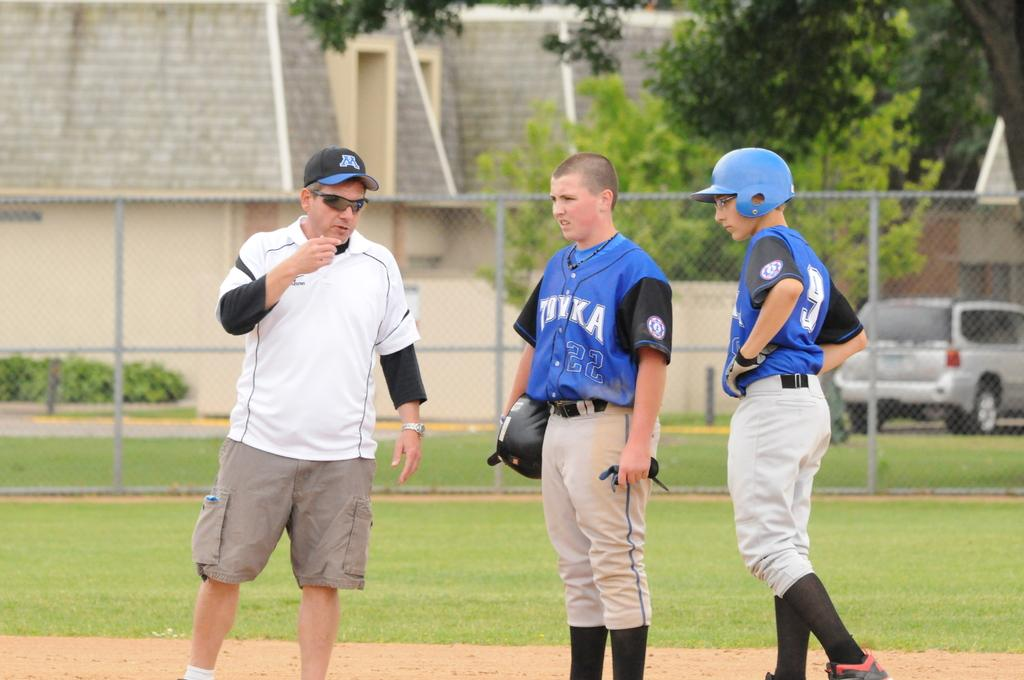<image>
Present a compact description of the photo's key features. two players and a man and one boy is wearing 22 